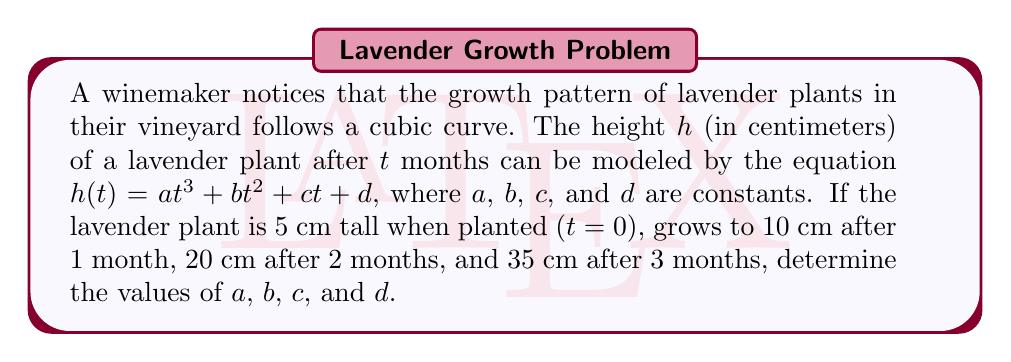Solve this math problem. Let's solve this step-by-step:

1) We have four conditions:
   $h(0) = d = 5$
   $h(1) = a + b + c + d = 10$
   $h(2) = 8a + 4b + 2c + d = 20$
   $h(3) = 27a + 9b + 3c + d = 35$

2) From the first condition, we know $d = 5$.

3) Substitute this into the other equations:
   $a + b + c = 5$
   $8a + 4b + 2c = 15$
   $27a + 9b + 3c = 30$

4) Subtract the first equation from the second:
   $7a + 3b + c = 10$

5) Subtract the first equation from the third:
   $26a + 8b + 2c = 25$

6) Multiply the equation from step 4 by 2 and subtract from the equation in step 5:
   $12a + 2b = 5$

7) From the equation in step 4, express $c$ in terms of $a$ and $b$:
   $c = 10 - 7a - 3b$

8) Substitute this into the equation from step 3:
   $a + b + (10 - 7a - 3b) = 5$
   $-6a - 2b = -5$
   $3a + b = \frac{5}{2}$

9) Now we have two equations:
   $12a + 2b = 5$
   $3a + b = \frac{5}{2}$

10) Multiply the second equation by 2 and subtract from the first:
    $6a = 0$
    $a = 0$

11) Substitute this back into $3a + b = \frac{5}{2}$:
    $b = \frac{5}{2}$

12) Now we can find $c$ from the equation in step 7:
    $c = 10 - 7(0) - 3(\frac{5}{2}) = \frac{5}{2}$

Therefore, $a = 0$, $b = \frac{5}{2}$, $c = \frac{5}{2}$, and $d = 5$.
Answer: $a = 0$, $b = \frac{5}{2}$, $c = \frac{5}{2}$, $d = 5$ 